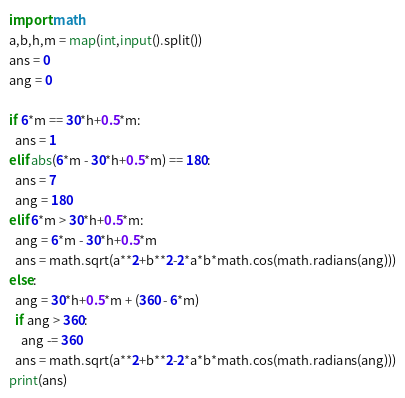Convert code to text. <code><loc_0><loc_0><loc_500><loc_500><_Python_>import math
a,b,h,m = map(int,input().split())
ans = 0
ang = 0

if 6*m == 30*h+0.5*m:
  ans = 1
elif abs(6*m - 30*h+0.5*m) == 180:
  ans = 7
  ang = 180
elif 6*m > 30*h+0.5*m:
  ang = 6*m - 30*h+0.5*m
  ans = math.sqrt(a**2+b**2-2*a*b*math.cos(math.radians(ang)))
else:
  ang = 30*h+0.5*m + (360 - 6*m)
  if ang > 360:
    ang -= 360
  ans = math.sqrt(a**2+b**2-2*a*b*math.cos(math.radians(ang)))
print(ans)</code> 